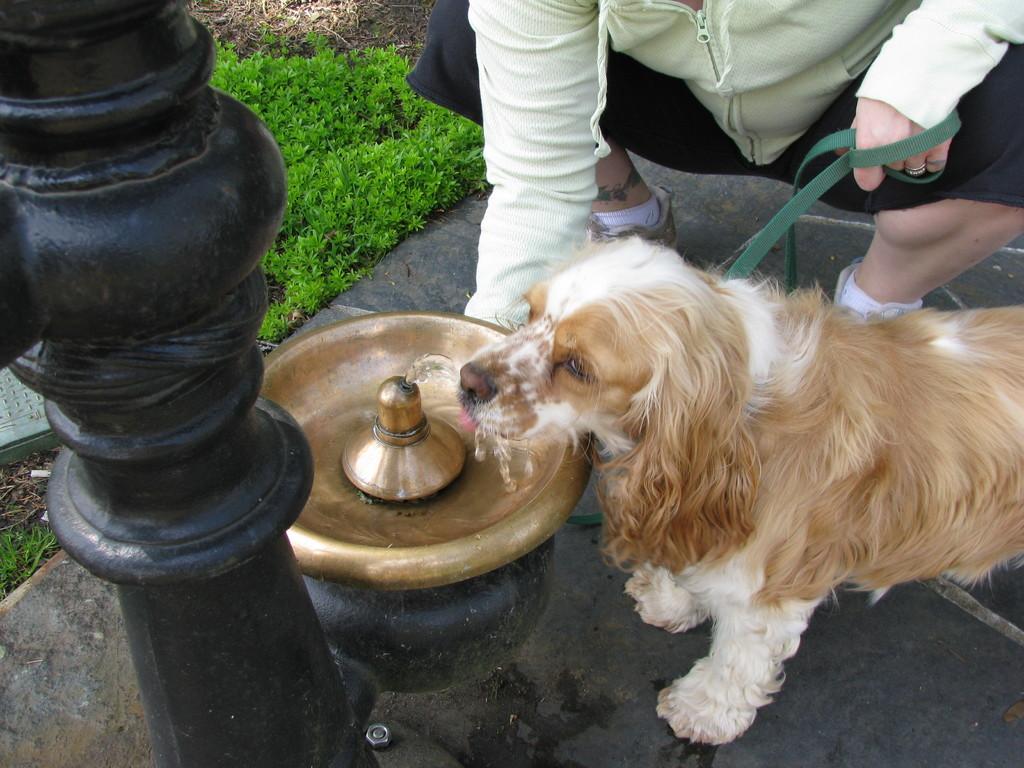Could you give a brief overview of what you see in this image? In this image we can see one animal, near that there is a container with water, beside we can see the pole, grass and one person is sitting. 